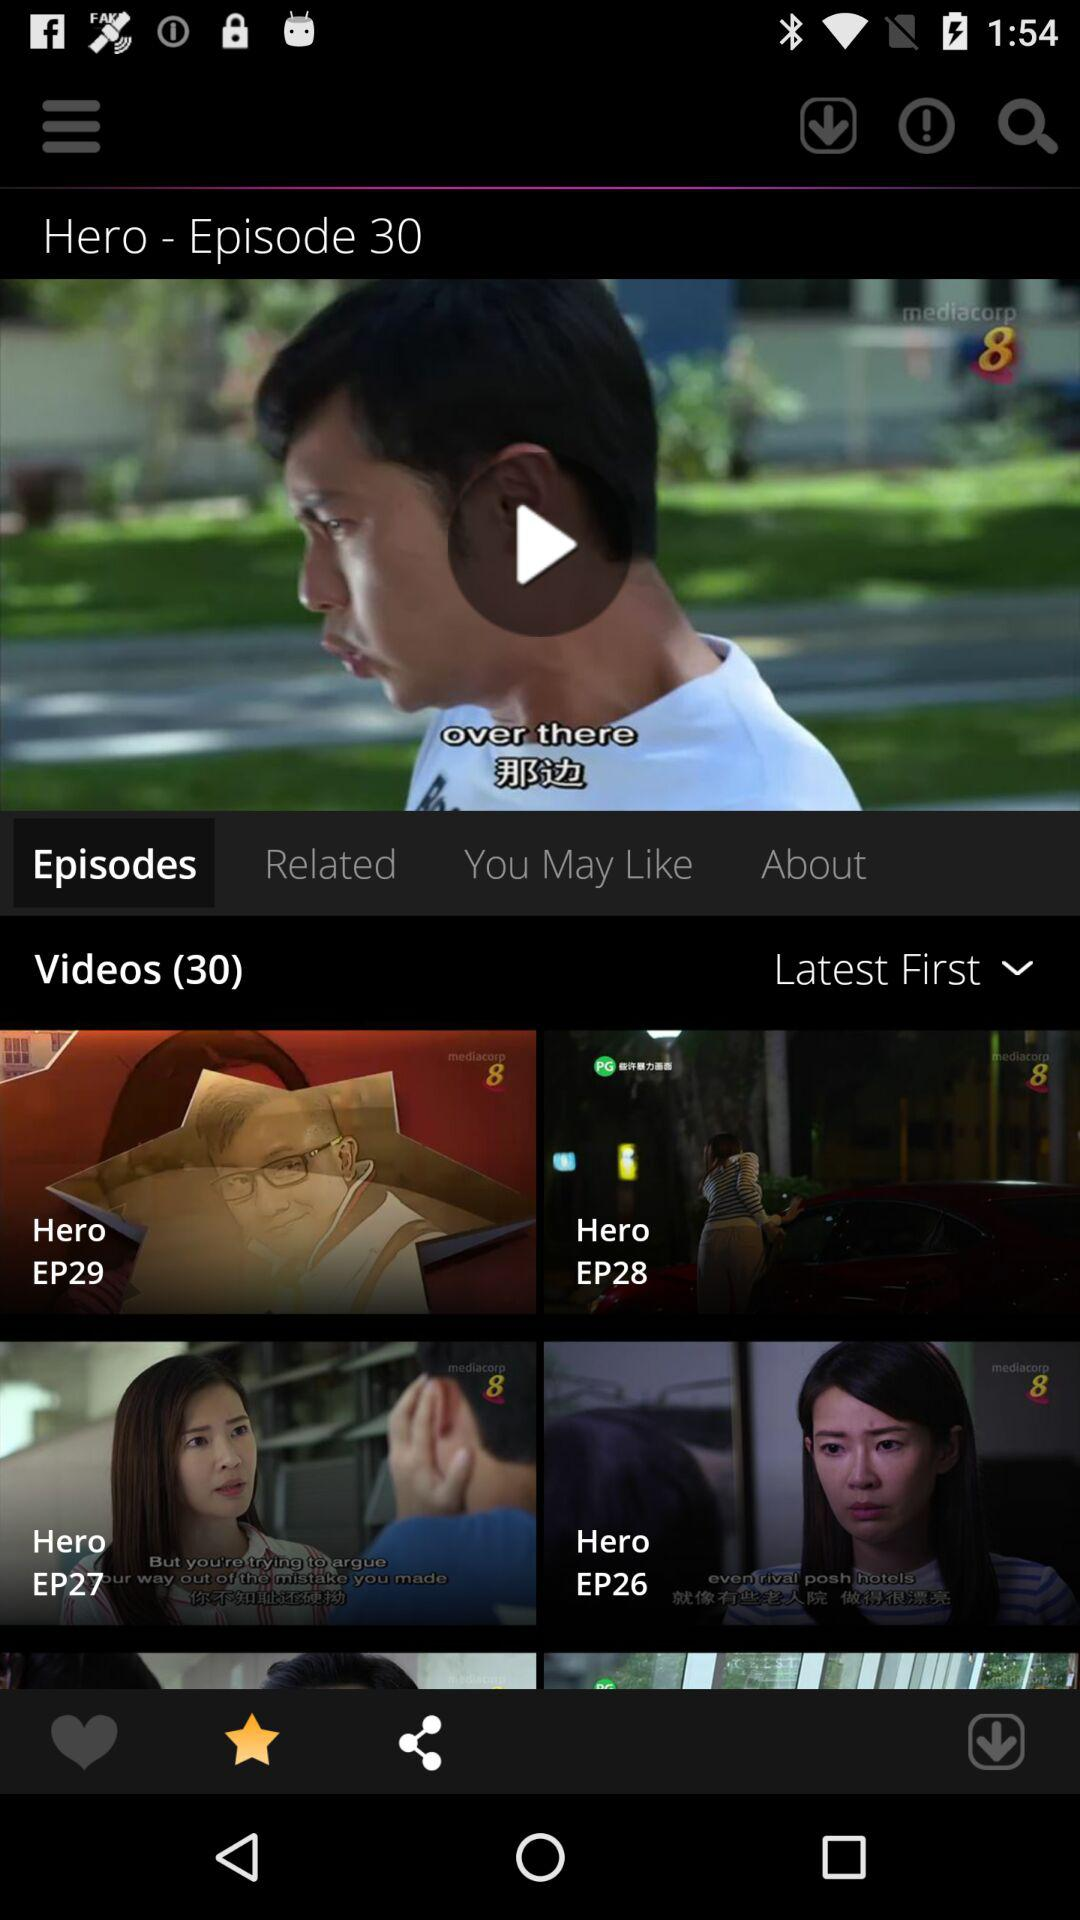How many episodes are there of "Hero"? There are 30 episodes of "Hero". 